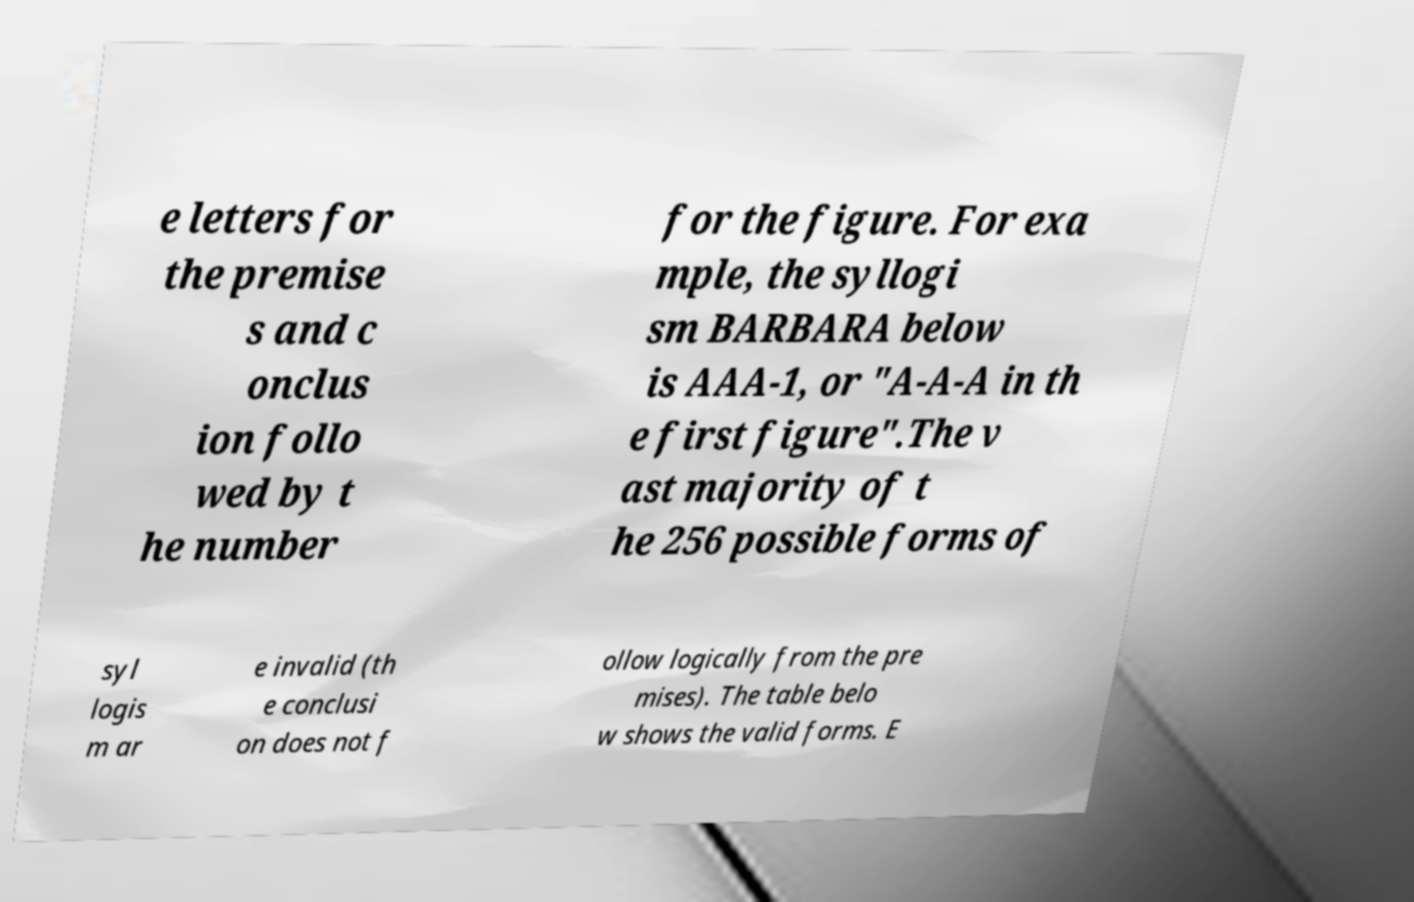Please identify and transcribe the text found in this image. e letters for the premise s and c onclus ion follo wed by t he number for the figure. For exa mple, the syllogi sm BARBARA below is AAA-1, or "A-A-A in th e first figure".The v ast majority of t he 256 possible forms of syl logis m ar e invalid (th e conclusi on does not f ollow logically from the pre mises). The table belo w shows the valid forms. E 